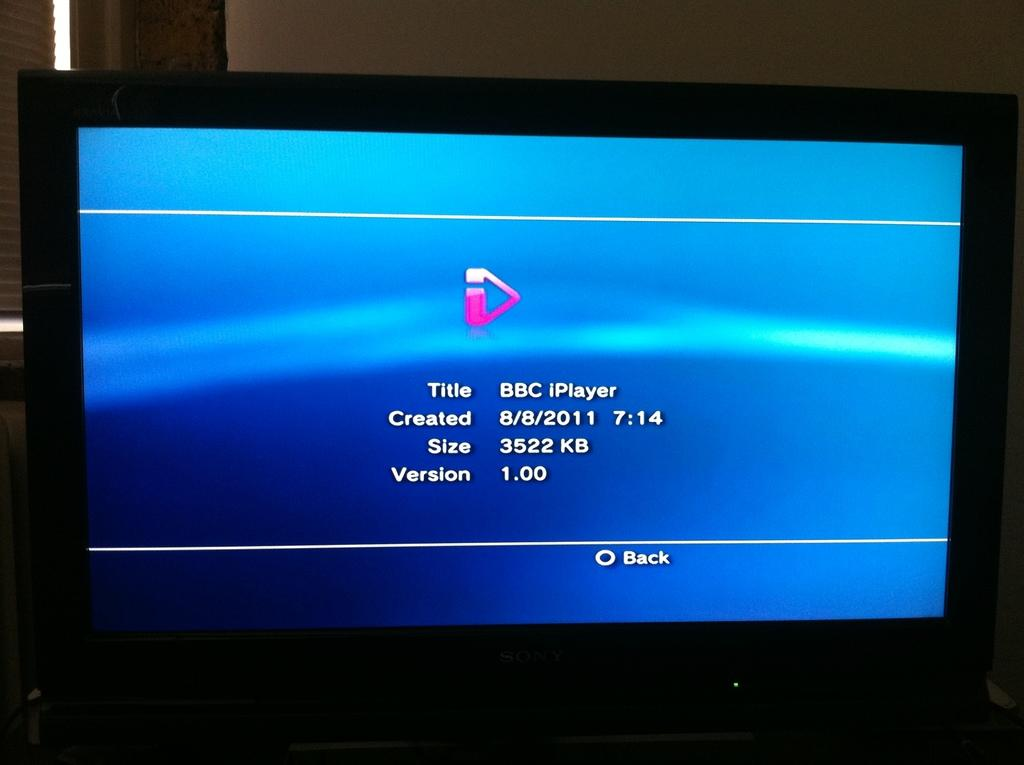<image>
Create a compact narrative representing the image presented. the word back is on the bottom of the blue screen 